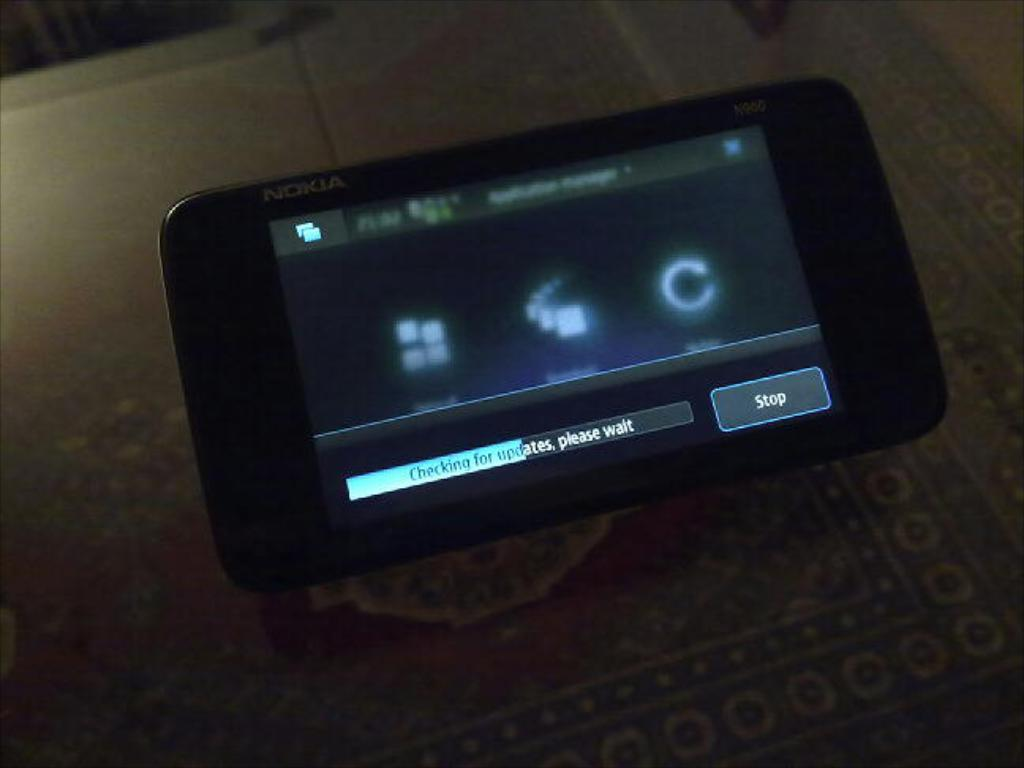<image>
Present a compact description of the photo's key features. nokia phone with screen that has on it checking for updates, please wait 